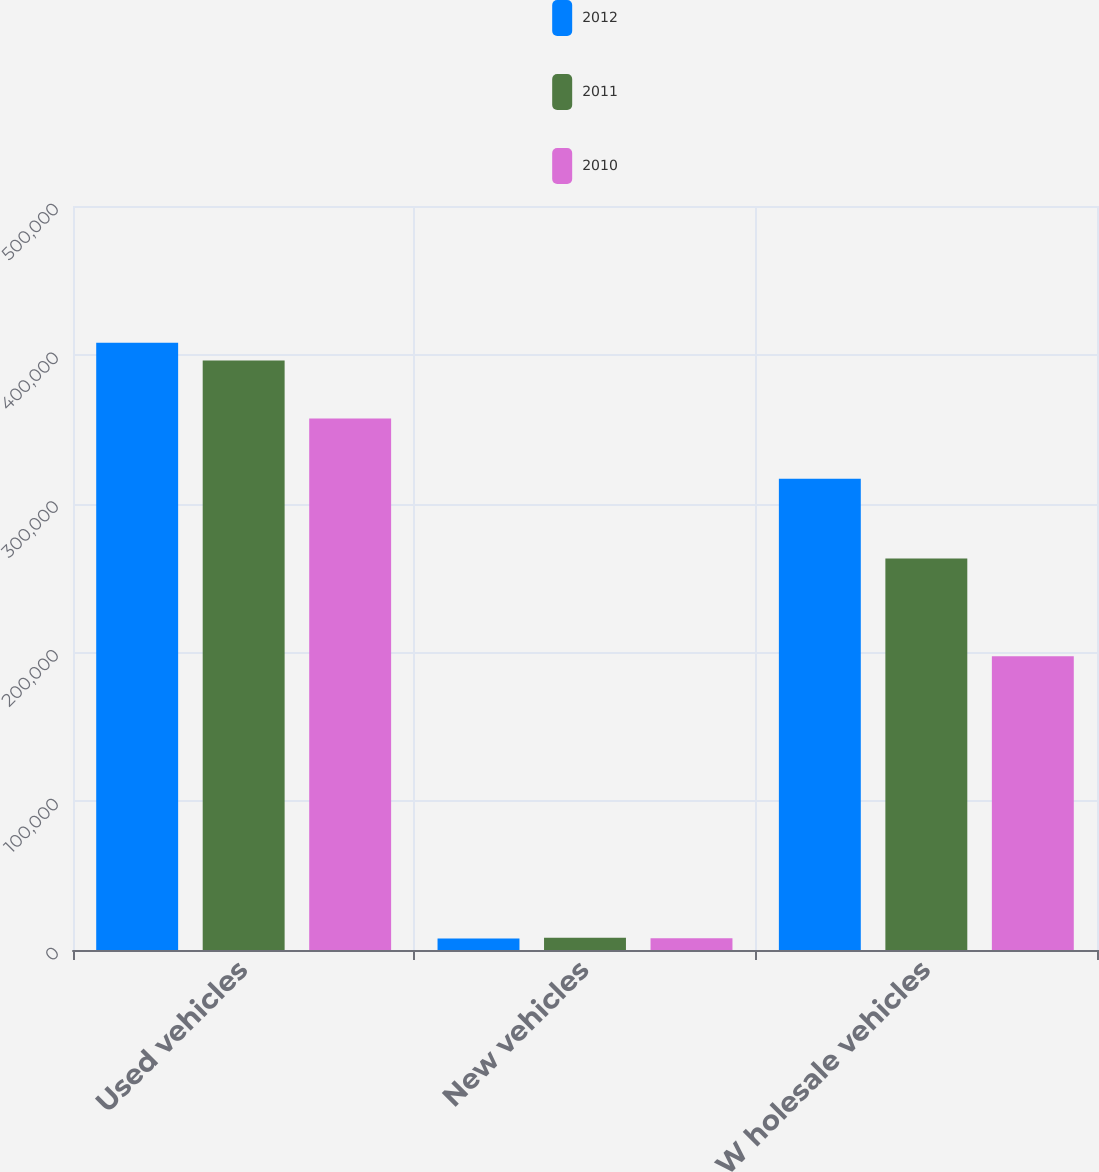Convert chart. <chart><loc_0><loc_0><loc_500><loc_500><stacked_bar_chart><ecel><fcel>Used vehicles<fcel>New vehicles<fcel>W holesale vehicles<nl><fcel>2012<fcel>408080<fcel>7679<fcel>316649<nl><fcel>2011<fcel>396181<fcel>8231<fcel>263061<nl><fcel>2010<fcel>357129<fcel>7851<fcel>197382<nl></chart> 